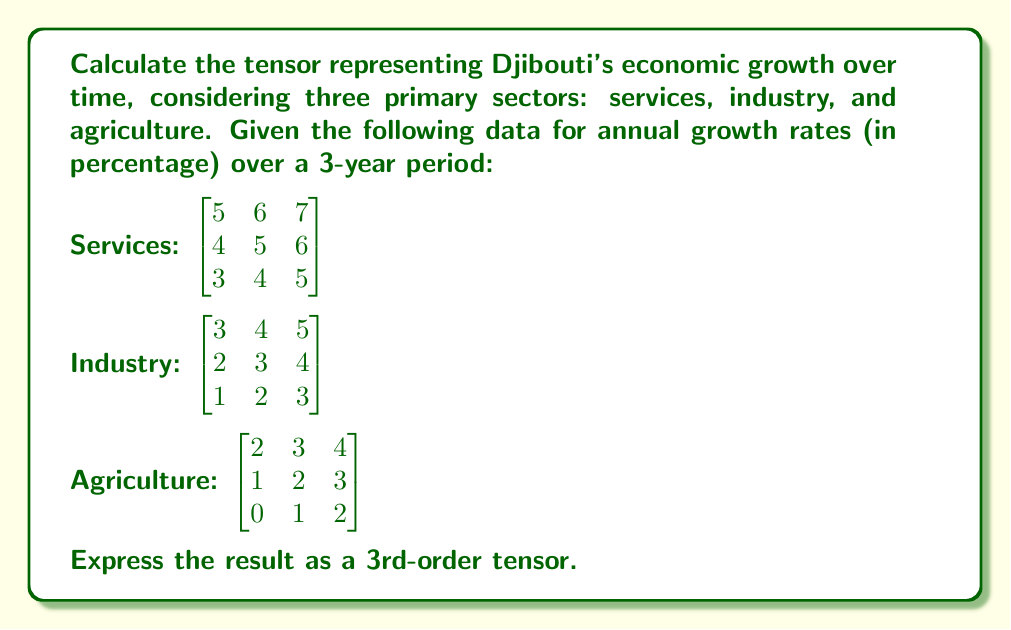Could you help me with this problem? To calculate the tensor representing Djibouti's economic growth over time, we need to combine the given matrices into a 3rd-order tensor. Each matrix represents a sector of the economy, and we'll stack these matrices to form the tensor.

Step 1: Define the tensor structure
Let's define our tensor $T$ as a 3x3x3 tensor, where:
- The first dimension represents the economic sectors (services, industry, agriculture)
- The second dimension represents the years (Year 1, Year 2, Year 3)
- The third dimension represents the sub-sectors within each main sector

Step 2: Construct the tensor
We can represent the tensor $T$ as follows:

$$T_{ijk} = \begin{bmatrix}
\begin{bmatrix} 5 & 6 & 7 \\ 4 & 5 & 6 \\ 3 & 4 & 5 \end{bmatrix} \\[2ex]
\begin{bmatrix} 3 & 4 & 5 \\ 2 & 3 & 4 \\ 1 & 2 & 3 \end{bmatrix} \\[2ex]
\begin{bmatrix} 2 & 3 & 4 \\ 1 & 2 & 3 \\ 0 & 1 & 2 \end{bmatrix}
\end{bmatrix}$$

Where:
- $i$ represents the sector (1 = services, 2 = industry, 3 = agriculture)
- $j$ represents the year (1 = Year 1, 2 = Year 2, 3 = Year 3)
- $k$ represents the sub-sector within each main sector

Step 3: Verify the tensor properties
This 3rd-order tensor satisfies the required properties:
1. It has three dimensions (3x3x3)
2. Each element $T_{ijk}$ represents the growth rate for a specific sector, year, and sub-sector
3. The tensor preserves the structure and relationships of the original data

Therefore, this tensor accurately represents Djibouti's economic growth over time for the given sectors and years.
Answer: $$T_{ijk} = \begin{bmatrix}
\begin{bmatrix} 5 & 6 & 7 \\ 4 & 5 & 6 \\ 3 & 4 & 5 \end{bmatrix} \\[2ex]
\begin{bmatrix} 3 & 4 & 5 \\ 2 & 3 & 4 \\ 1 & 2 & 3 \end{bmatrix} \\[2ex]
\begin{bmatrix} 2 & 3 & 4 \\ 1 & 2 & 3 \\ 0 & 1 & 2 \end{bmatrix}
\end{bmatrix}$$ 